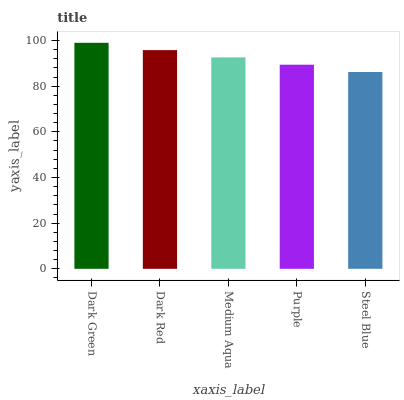Is Steel Blue the minimum?
Answer yes or no. Yes. Is Dark Green the maximum?
Answer yes or no. Yes. Is Dark Red the minimum?
Answer yes or no. No. Is Dark Red the maximum?
Answer yes or no. No. Is Dark Green greater than Dark Red?
Answer yes or no. Yes. Is Dark Red less than Dark Green?
Answer yes or no. Yes. Is Dark Red greater than Dark Green?
Answer yes or no. No. Is Dark Green less than Dark Red?
Answer yes or no. No. Is Medium Aqua the high median?
Answer yes or no. Yes. Is Medium Aqua the low median?
Answer yes or no. Yes. Is Dark Red the high median?
Answer yes or no. No. Is Purple the low median?
Answer yes or no. No. 